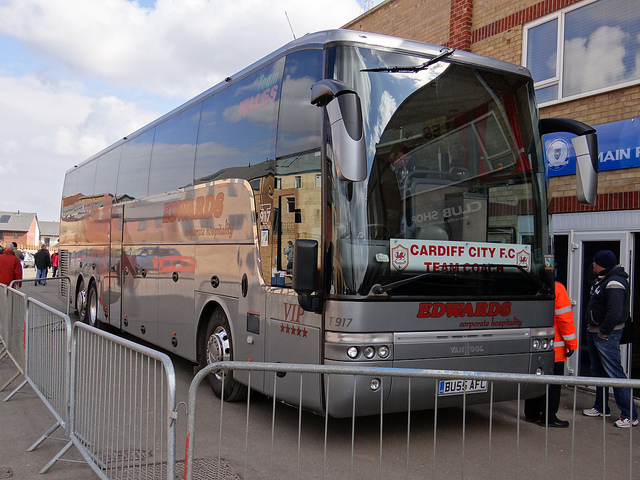Please extract the text content from this image. VIP 917 EDWARDS AFC BUSS COACH TEAM CLUB SHO F.C CITY CARDIFF 